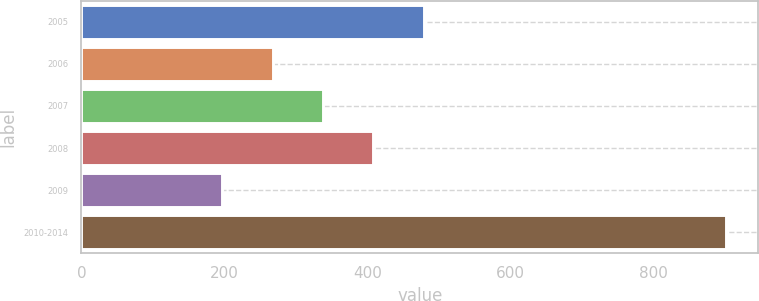Convert chart. <chart><loc_0><loc_0><loc_500><loc_500><bar_chart><fcel>2005<fcel>2006<fcel>2007<fcel>2008<fcel>2009<fcel>2010-2014<nl><fcel>479<fcel>267.5<fcel>338<fcel>408.5<fcel>197<fcel>902<nl></chart> 